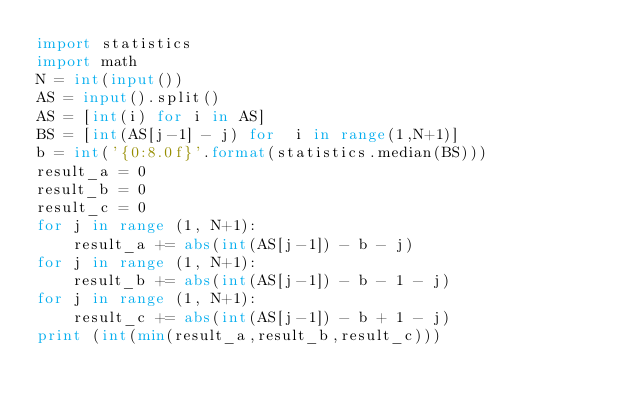Convert code to text. <code><loc_0><loc_0><loc_500><loc_500><_Python_>import statistics
import math
N = int(input())
AS = input().split()
AS = [int(i) for i in AS]
BS = [int(AS[j-1] - j) for  i in range(1,N+1)]
b = int('{0:8.0f}'.format(statistics.median(BS)))
result_a = 0
result_b = 0
result_c = 0
for j in range (1, N+1):
    result_a += abs(int(AS[j-1]) - b - j)
for j in range (1, N+1):
    result_b += abs(int(AS[j-1]) - b - 1 - j)
for j in range (1, N+1):
    result_c += abs(int(AS[j-1]) - b + 1 - j)
print (int(min(result_a,result_b,result_c)))</code> 